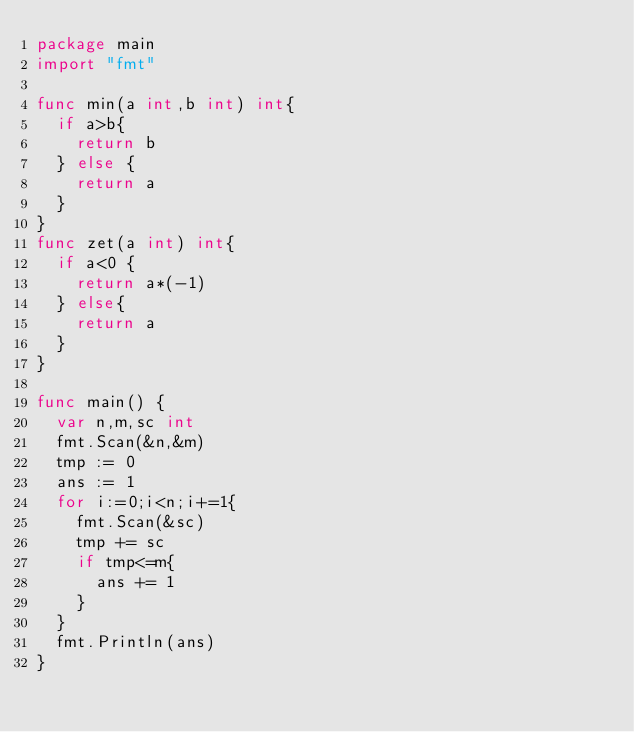<code> <loc_0><loc_0><loc_500><loc_500><_Go_>package main
import "fmt"

func min(a int,b int) int{
	if a>b{
		return b
	} else {
		return a
	}
}
func zet(a int) int{
	if a<0 {
		return a*(-1)
	} else{
		return a
	}
}

func main() {
	var n,m,sc int
	fmt.Scan(&n,&m)
	tmp := 0
	ans := 1
	for i:=0;i<n;i+=1{
		fmt.Scan(&sc)
		tmp += sc
		if tmp<=m{
			ans += 1
		}
	}
	fmt.Println(ans)
}</code> 